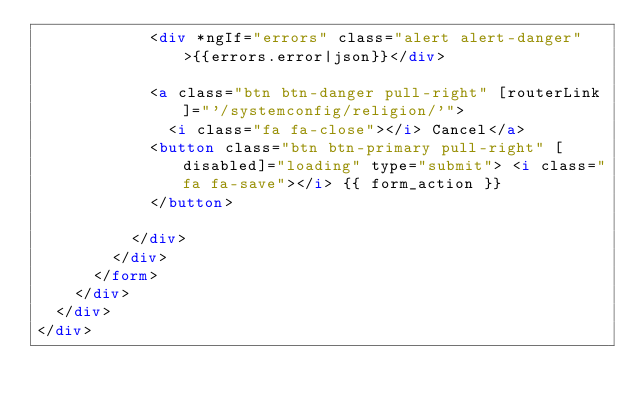<code> <loc_0><loc_0><loc_500><loc_500><_HTML_>            <div *ngIf="errors" class="alert alert-danger">{{errors.error|json}}</div>

            <a class="btn btn-danger pull-right" [routerLink]="'/systemconfig/religion/'">
              <i class="fa fa-close"></i> Cancel</a>
            <button class="btn btn-primary pull-right" [disabled]="loading" type="submit"> <i class="fa fa-save"></i> {{ form_action }}
            </button>

          </div>
        </div>
      </form>
    </div>
  </div>
</div>
</code> 